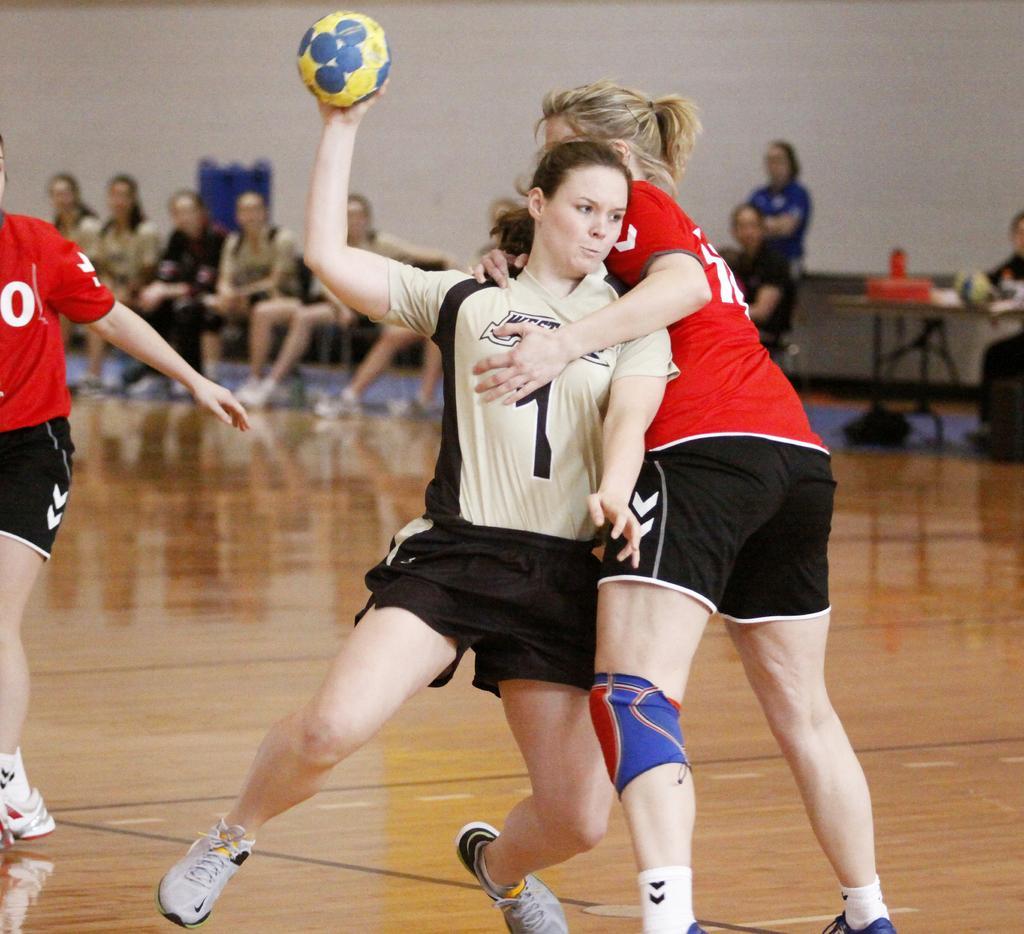Please provide a concise description of this image. This picture shows a woman, playing with a ball in his, in her hand. There are two teams here. In the background there are some people sitting in the chairs and watching the game. We can observe a wall too. 